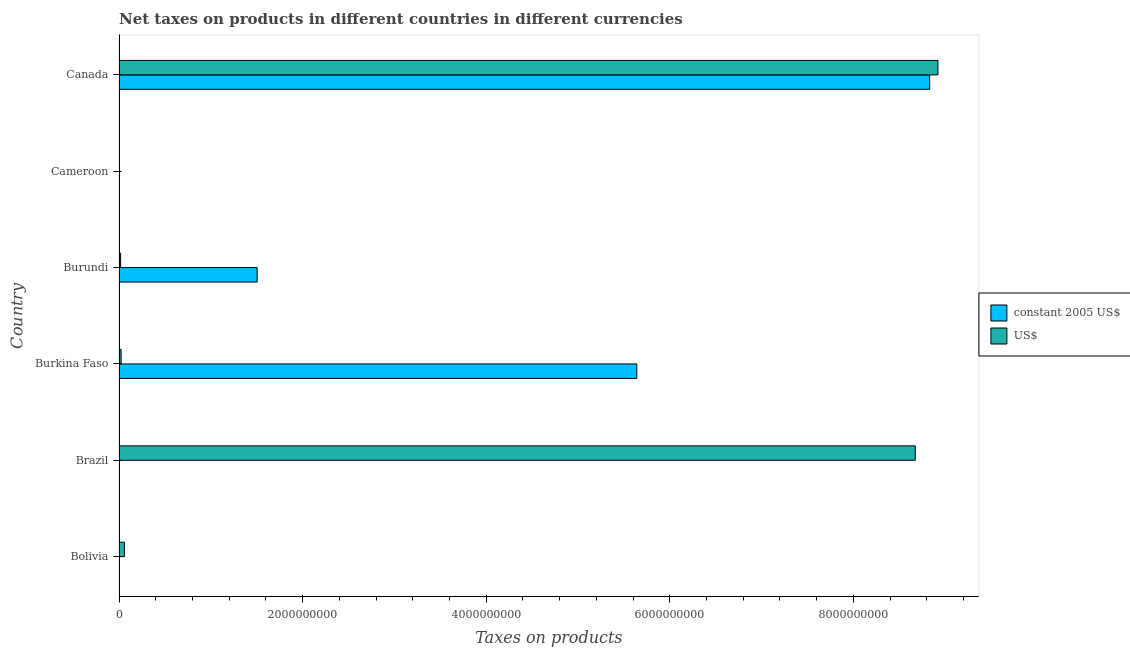How many groups of bars are there?
Your answer should be very brief. 6. What is the label of the 4th group of bars from the top?
Make the answer very short. Burkina Faso. What is the net taxes in constant 2005 us$ in Brazil?
Provide a short and direct response. 0.02. Across all countries, what is the maximum net taxes in constant 2005 us$?
Keep it short and to the point. 8.83e+09. Across all countries, what is the minimum net taxes in constant 2005 us$?
Provide a succinct answer. 0.02. What is the total net taxes in constant 2005 us$ in the graph?
Your answer should be very brief. 1.60e+1. What is the difference between the net taxes in constant 2005 us$ in Burundi and that in Canada?
Give a very brief answer. -7.33e+09. What is the difference between the net taxes in us$ in Canada and the net taxes in constant 2005 us$ in Bolivia?
Make the answer very short. 8.92e+09. What is the average net taxes in us$ per country?
Keep it short and to the point. 2.95e+09. What is the difference between the net taxes in constant 2005 us$ and net taxes in us$ in Burkina Faso?
Your answer should be very brief. 5.62e+09. In how many countries, is the net taxes in constant 2005 us$ greater than 3600000000 units?
Give a very brief answer. 2. What is the ratio of the net taxes in constant 2005 us$ in Brazil to that in Cameroon?
Your answer should be very brief. 0. Is the difference between the net taxes in constant 2005 us$ in Bolivia and Burundi greater than the difference between the net taxes in us$ in Bolivia and Burundi?
Provide a succinct answer. No. What is the difference between the highest and the second highest net taxes in us$?
Provide a short and direct response. 2.47e+08. What is the difference between the highest and the lowest net taxes in us$?
Your response must be concise. 8.92e+09. Is the sum of the net taxes in us$ in Bolivia and Burundi greater than the maximum net taxes in constant 2005 us$ across all countries?
Provide a short and direct response. No. What does the 1st bar from the top in Cameroon represents?
Your answer should be very brief. US$. What does the 1st bar from the bottom in Brazil represents?
Give a very brief answer. Constant 2005 us$. How many countries are there in the graph?
Keep it short and to the point. 6. Are the values on the major ticks of X-axis written in scientific E-notation?
Ensure brevity in your answer.  No. Does the graph contain any zero values?
Provide a short and direct response. No. Does the graph contain grids?
Make the answer very short. No. What is the title of the graph?
Offer a very short reply. Net taxes on products in different countries in different currencies. Does "Electricity" appear as one of the legend labels in the graph?
Provide a short and direct response. No. What is the label or title of the X-axis?
Provide a succinct answer. Taxes on products. What is the label or title of the Y-axis?
Make the answer very short. Country. What is the Taxes on products of constant 2005 US$ in Bolivia?
Provide a succinct answer. 776. What is the Taxes on products in US$ in Bolivia?
Your answer should be very brief. 5.84e+07. What is the Taxes on products in constant 2005 US$ in Brazil?
Provide a succinct answer. 0.02. What is the Taxes on products of US$ in Brazil?
Provide a short and direct response. 8.68e+09. What is the Taxes on products of constant 2005 US$ in Burkina Faso?
Offer a terse response. 5.64e+09. What is the Taxes on products in US$ in Burkina Faso?
Give a very brief answer. 2.24e+07. What is the Taxes on products of constant 2005 US$ in Burundi?
Provide a short and direct response. 1.50e+09. What is the Taxes on products of US$ in Burundi?
Your answer should be compact. 1.72e+07. What is the Taxes on products of constant 2005 US$ in Cameroon?
Keep it short and to the point. 8.54e+05. What is the Taxes on products of US$ in Cameroon?
Offer a terse response. 3235.55. What is the Taxes on products of constant 2005 US$ in Canada?
Your answer should be compact. 8.83e+09. What is the Taxes on products in US$ in Canada?
Provide a short and direct response. 8.92e+09. Across all countries, what is the maximum Taxes on products in constant 2005 US$?
Provide a short and direct response. 8.83e+09. Across all countries, what is the maximum Taxes on products in US$?
Offer a very short reply. 8.92e+09. Across all countries, what is the minimum Taxes on products of constant 2005 US$?
Ensure brevity in your answer.  0.02. Across all countries, what is the minimum Taxes on products of US$?
Offer a terse response. 3235.55. What is the total Taxes on products of constant 2005 US$ in the graph?
Your answer should be compact. 1.60e+1. What is the total Taxes on products of US$ in the graph?
Make the answer very short. 1.77e+1. What is the difference between the Taxes on products of constant 2005 US$ in Bolivia and that in Brazil?
Make the answer very short. 775.98. What is the difference between the Taxes on products in US$ in Bolivia and that in Brazil?
Your response must be concise. -8.62e+09. What is the difference between the Taxes on products of constant 2005 US$ in Bolivia and that in Burkina Faso?
Keep it short and to the point. -5.64e+09. What is the difference between the Taxes on products of US$ in Bolivia and that in Burkina Faso?
Make the answer very short. 3.60e+07. What is the difference between the Taxes on products of constant 2005 US$ in Bolivia and that in Burundi?
Provide a short and direct response. -1.50e+09. What is the difference between the Taxes on products of US$ in Bolivia and that in Burundi?
Keep it short and to the point. 4.12e+07. What is the difference between the Taxes on products of constant 2005 US$ in Bolivia and that in Cameroon?
Your response must be concise. -8.53e+05. What is the difference between the Taxes on products in US$ in Bolivia and that in Cameroon?
Make the answer very short. 5.84e+07. What is the difference between the Taxes on products in constant 2005 US$ in Bolivia and that in Canada?
Your answer should be compact. -8.83e+09. What is the difference between the Taxes on products of US$ in Bolivia and that in Canada?
Make the answer very short. -8.86e+09. What is the difference between the Taxes on products of constant 2005 US$ in Brazil and that in Burkina Faso?
Your response must be concise. -5.64e+09. What is the difference between the Taxes on products of US$ in Brazil and that in Burkina Faso?
Ensure brevity in your answer.  8.65e+09. What is the difference between the Taxes on products of constant 2005 US$ in Brazil and that in Burundi?
Offer a terse response. -1.50e+09. What is the difference between the Taxes on products of US$ in Brazil and that in Burundi?
Give a very brief answer. 8.66e+09. What is the difference between the Taxes on products in constant 2005 US$ in Brazil and that in Cameroon?
Your answer should be compact. -8.54e+05. What is the difference between the Taxes on products of US$ in Brazil and that in Cameroon?
Make the answer very short. 8.68e+09. What is the difference between the Taxes on products of constant 2005 US$ in Brazil and that in Canada?
Ensure brevity in your answer.  -8.83e+09. What is the difference between the Taxes on products of US$ in Brazil and that in Canada?
Offer a very short reply. -2.47e+08. What is the difference between the Taxes on products in constant 2005 US$ in Burkina Faso and that in Burundi?
Offer a very short reply. 4.14e+09. What is the difference between the Taxes on products of US$ in Burkina Faso and that in Burundi?
Offer a terse response. 5.19e+06. What is the difference between the Taxes on products of constant 2005 US$ in Burkina Faso and that in Cameroon?
Your response must be concise. 5.64e+09. What is the difference between the Taxes on products in US$ in Burkina Faso and that in Cameroon?
Your answer should be compact. 2.24e+07. What is the difference between the Taxes on products of constant 2005 US$ in Burkina Faso and that in Canada?
Offer a terse response. -3.19e+09. What is the difference between the Taxes on products of US$ in Burkina Faso and that in Canada?
Provide a succinct answer. -8.90e+09. What is the difference between the Taxes on products of constant 2005 US$ in Burundi and that in Cameroon?
Offer a very short reply. 1.50e+09. What is the difference between the Taxes on products in US$ in Burundi and that in Cameroon?
Provide a short and direct response. 1.72e+07. What is the difference between the Taxes on products in constant 2005 US$ in Burundi and that in Canada?
Your response must be concise. -7.33e+09. What is the difference between the Taxes on products of US$ in Burundi and that in Canada?
Provide a short and direct response. -8.90e+09. What is the difference between the Taxes on products in constant 2005 US$ in Cameroon and that in Canada?
Your answer should be compact. -8.83e+09. What is the difference between the Taxes on products in US$ in Cameroon and that in Canada?
Ensure brevity in your answer.  -8.92e+09. What is the difference between the Taxes on products in constant 2005 US$ in Bolivia and the Taxes on products in US$ in Brazil?
Ensure brevity in your answer.  -8.68e+09. What is the difference between the Taxes on products of constant 2005 US$ in Bolivia and the Taxes on products of US$ in Burkina Faso?
Offer a terse response. -2.24e+07. What is the difference between the Taxes on products in constant 2005 US$ in Bolivia and the Taxes on products in US$ in Burundi?
Give a very brief answer. -1.72e+07. What is the difference between the Taxes on products in constant 2005 US$ in Bolivia and the Taxes on products in US$ in Cameroon?
Provide a short and direct response. -2459.55. What is the difference between the Taxes on products of constant 2005 US$ in Bolivia and the Taxes on products of US$ in Canada?
Offer a very short reply. -8.92e+09. What is the difference between the Taxes on products of constant 2005 US$ in Brazil and the Taxes on products of US$ in Burkina Faso?
Your answer should be compact. -2.24e+07. What is the difference between the Taxes on products in constant 2005 US$ in Brazil and the Taxes on products in US$ in Burundi?
Your answer should be compact. -1.72e+07. What is the difference between the Taxes on products in constant 2005 US$ in Brazil and the Taxes on products in US$ in Cameroon?
Your answer should be compact. -3235.53. What is the difference between the Taxes on products of constant 2005 US$ in Brazil and the Taxes on products of US$ in Canada?
Make the answer very short. -8.92e+09. What is the difference between the Taxes on products of constant 2005 US$ in Burkina Faso and the Taxes on products of US$ in Burundi?
Offer a very short reply. 5.62e+09. What is the difference between the Taxes on products of constant 2005 US$ in Burkina Faso and the Taxes on products of US$ in Cameroon?
Your response must be concise. 5.64e+09. What is the difference between the Taxes on products in constant 2005 US$ in Burkina Faso and the Taxes on products in US$ in Canada?
Make the answer very short. -3.28e+09. What is the difference between the Taxes on products in constant 2005 US$ in Burundi and the Taxes on products in US$ in Cameroon?
Offer a terse response. 1.50e+09. What is the difference between the Taxes on products of constant 2005 US$ in Burundi and the Taxes on products of US$ in Canada?
Your answer should be very brief. -7.42e+09. What is the difference between the Taxes on products in constant 2005 US$ in Cameroon and the Taxes on products in US$ in Canada?
Provide a succinct answer. -8.92e+09. What is the average Taxes on products in constant 2005 US$ per country?
Keep it short and to the point. 2.66e+09. What is the average Taxes on products in US$ per country?
Offer a very short reply. 2.95e+09. What is the difference between the Taxes on products in constant 2005 US$ and Taxes on products in US$ in Bolivia?
Keep it short and to the point. -5.84e+07. What is the difference between the Taxes on products in constant 2005 US$ and Taxes on products in US$ in Brazil?
Ensure brevity in your answer.  -8.68e+09. What is the difference between the Taxes on products in constant 2005 US$ and Taxes on products in US$ in Burkina Faso?
Provide a short and direct response. 5.62e+09. What is the difference between the Taxes on products in constant 2005 US$ and Taxes on products in US$ in Burundi?
Keep it short and to the point. 1.49e+09. What is the difference between the Taxes on products of constant 2005 US$ and Taxes on products of US$ in Cameroon?
Provide a short and direct response. 8.51e+05. What is the difference between the Taxes on products of constant 2005 US$ and Taxes on products of US$ in Canada?
Keep it short and to the point. -9.01e+07. What is the ratio of the Taxes on products of constant 2005 US$ in Bolivia to that in Brazil?
Your answer should be very brief. 4.15e+04. What is the ratio of the Taxes on products of US$ in Bolivia to that in Brazil?
Offer a very short reply. 0.01. What is the ratio of the Taxes on products of constant 2005 US$ in Bolivia to that in Burkina Faso?
Your answer should be very brief. 0. What is the ratio of the Taxes on products of US$ in Bolivia to that in Burkina Faso?
Ensure brevity in your answer.  2.61. What is the ratio of the Taxes on products of constant 2005 US$ in Bolivia to that in Burundi?
Ensure brevity in your answer.  0. What is the ratio of the Taxes on products in US$ in Bolivia to that in Burundi?
Keep it short and to the point. 3.39. What is the ratio of the Taxes on products in constant 2005 US$ in Bolivia to that in Cameroon?
Keep it short and to the point. 0. What is the ratio of the Taxes on products in US$ in Bolivia to that in Cameroon?
Provide a short and direct response. 1.80e+04. What is the ratio of the Taxes on products in constant 2005 US$ in Bolivia to that in Canada?
Keep it short and to the point. 0. What is the ratio of the Taxes on products in US$ in Bolivia to that in Canada?
Your answer should be very brief. 0.01. What is the ratio of the Taxes on products of US$ in Brazil to that in Burkina Faso?
Give a very brief answer. 387.59. What is the ratio of the Taxes on products of constant 2005 US$ in Brazil to that in Burundi?
Provide a succinct answer. 0. What is the ratio of the Taxes on products in US$ in Brazil to that in Burundi?
Your answer should be very brief. 504.47. What is the ratio of the Taxes on products in constant 2005 US$ in Brazil to that in Cameroon?
Ensure brevity in your answer.  0. What is the ratio of the Taxes on products in US$ in Brazil to that in Cameroon?
Give a very brief answer. 2.68e+06. What is the ratio of the Taxes on products in constant 2005 US$ in Brazil to that in Canada?
Your response must be concise. 0. What is the ratio of the Taxes on products in US$ in Brazil to that in Canada?
Keep it short and to the point. 0.97. What is the ratio of the Taxes on products in constant 2005 US$ in Burkina Faso to that in Burundi?
Offer a terse response. 3.75. What is the ratio of the Taxes on products in US$ in Burkina Faso to that in Burundi?
Give a very brief answer. 1.3. What is the ratio of the Taxes on products in constant 2005 US$ in Burkina Faso to that in Cameroon?
Your answer should be compact. 6606.77. What is the ratio of the Taxes on products of US$ in Burkina Faso to that in Cameroon?
Your answer should be very brief. 6917.5. What is the ratio of the Taxes on products in constant 2005 US$ in Burkina Faso to that in Canada?
Give a very brief answer. 0.64. What is the ratio of the Taxes on products of US$ in Burkina Faso to that in Canada?
Your answer should be very brief. 0. What is the ratio of the Taxes on products of constant 2005 US$ in Burundi to that in Cameroon?
Your response must be concise. 1762.36. What is the ratio of the Taxes on products of US$ in Burundi to that in Cameroon?
Make the answer very short. 5314.88. What is the ratio of the Taxes on products in constant 2005 US$ in Burundi to that in Canada?
Provide a succinct answer. 0.17. What is the ratio of the Taxes on products of US$ in Burundi to that in Canada?
Give a very brief answer. 0. What is the ratio of the Taxes on products of constant 2005 US$ in Cameroon to that in Canada?
Keep it short and to the point. 0. What is the ratio of the Taxes on products in US$ in Cameroon to that in Canada?
Make the answer very short. 0. What is the difference between the highest and the second highest Taxes on products of constant 2005 US$?
Offer a terse response. 3.19e+09. What is the difference between the highest and the second highest Taxes on products of US$?
Give a very brief answer. 2.47e+08. What is the difference between the highest and the lowest Taxes on products in constant 2005 US$?
Your answer should be very brief. 8.83e+09. What is the difference between the highest and the lowest Taxes on products in US$?
Your answer should be very brief. 8.92e+09. 